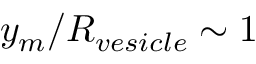Convert formula to latex. <formula><loc_0><loc_0><loc_500><loc_500>y _ { m } / R _ { v e s i c l e } \sim 1</formula> 